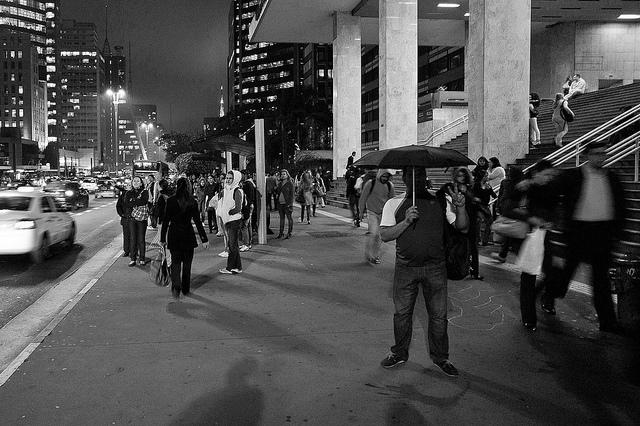What time of day is it?
Quick response, please. Night. Is it a clear night?
Keep it brief. Yes. Is it raining?
Quick response, please. No. Is the ground wet?
Give a very brief answer. No. Is it cold outside?
Be succinct. Yes. What is the man in the foreground using to shield himself from the rain?
Short answer required. Umbrella. 